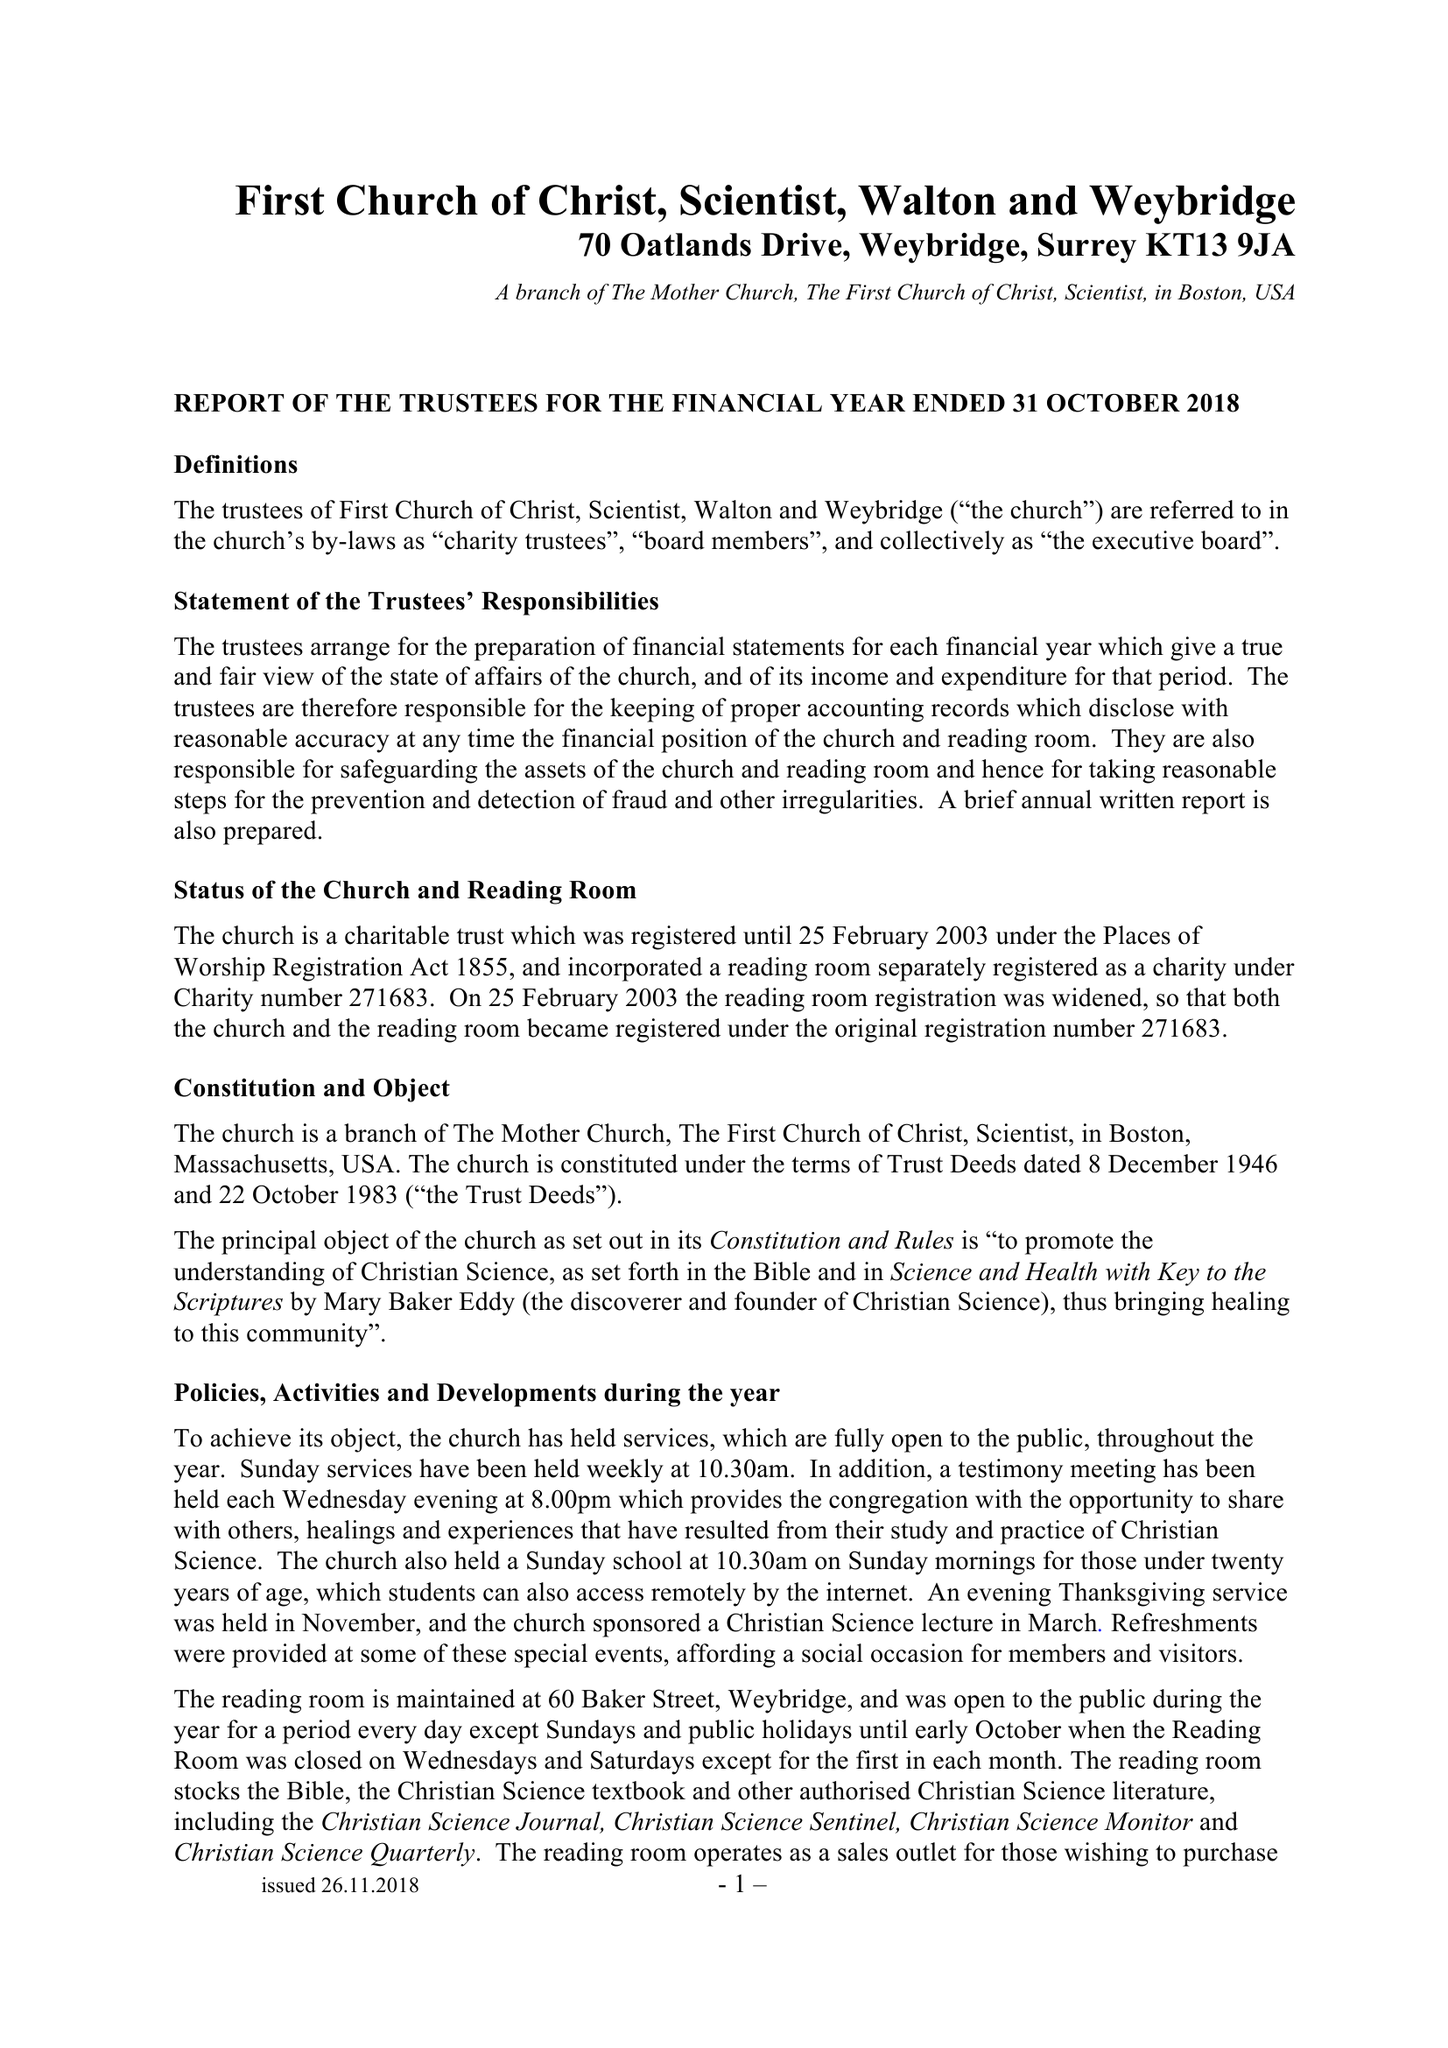What is the value for the charity_name?
Answer the question using a single word or phrase. First Church Of Christ , Scientist, Walton and Weybridge 